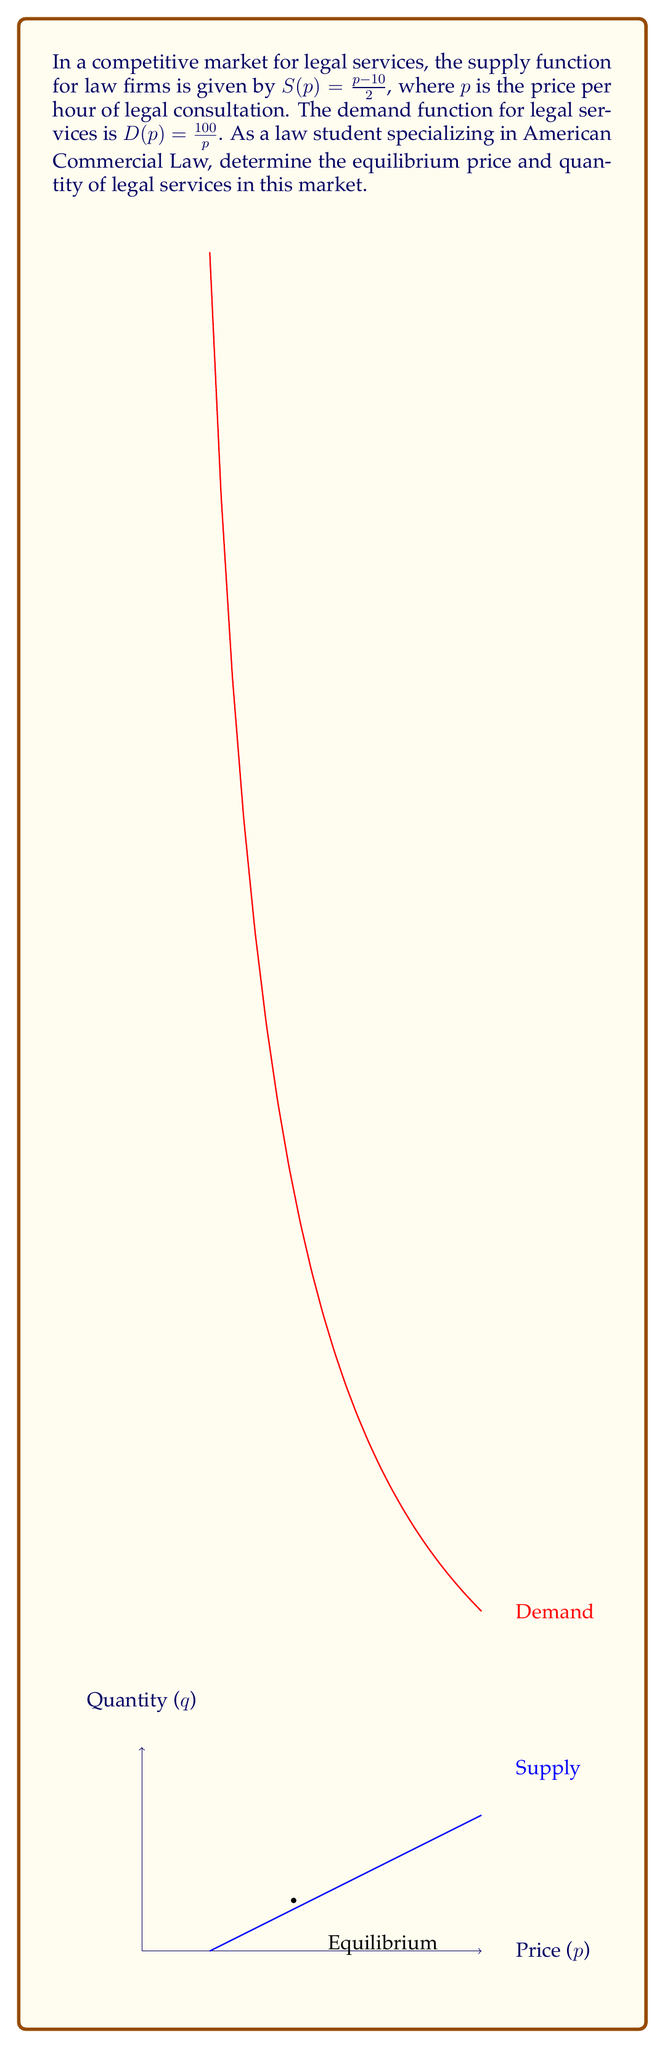What is the answer to this math problem? To find the market equilibrium, we need to find the point where supply equals demand:

1) Set the supply and demand functions equal to each other:
   $$\frac{p-10}{2} = \frac{100}{p}$$

2) Multiply both sides by $2p$ to eliminate fractions:
   $$(p-10)p = 200$$

3) Expand the left side:
   $$p^2 - 10p = 200$$

4) Rearrange to standard quadratic form:
   $$p^2 - 10p - 200 = 0$$

5) Solve using the quadratic formula $\frac{-b \pm \sqrt{b^2 - 4ac}}{2a}$:
   $$p = \frac{10 \pm \sqrt{100 + 800}}{2} = \frac{10 \pm \sqrt{900}}{2} = \frac{10 \pm 30}{2}$$

6) This gives us two solutions: $p = 20$ or $p = -10$. Since price cannot be negative, we take $p = 20$.

7) To find the equilibrium quantity, substitute $p = 20$ into either the supply or demand function:
   $$q = S(20) = \frac{20-10}{2} = 5$$

Therefore, the equilibrium price is $20 per hour, and the equilibrium quantity is 5 hours of legal consultation.
Answer: Equilibrium price: $20 per hour; Equilibrium quantity: 5 hours 